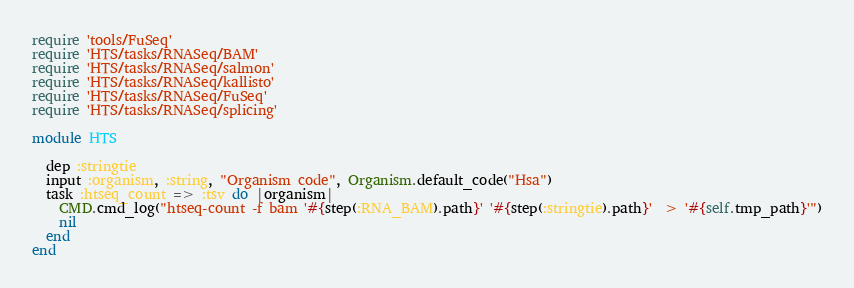<code> <loc_0><loc_0><loc_500><loc_500><_Ruby_>require 'tools/FuSeq'
require 'HTS/tasks/RNASeq/BAM'
require 'HTS/tasks/RNASeq/salmon'
require 'HTS/tasks/RNASeq/kallisto'
require 'HTS/tasks/RNASeq/FuSeq'
require 'HTS/tasks/RNASeq/splicing'

module HTS

  dep :stringtie
  input :organism, :string, "Organism code", Organism.default_code("Hsa")
  task :htseq_count => :tsv do |organism|
    CMD.cmd_log("htseq-count -f bam '#{step(:RNA_BAM).path}' '#{step(:stringtie).path}'  > '#{self.tmp_path}'")
    nil
  end
end
</code> 